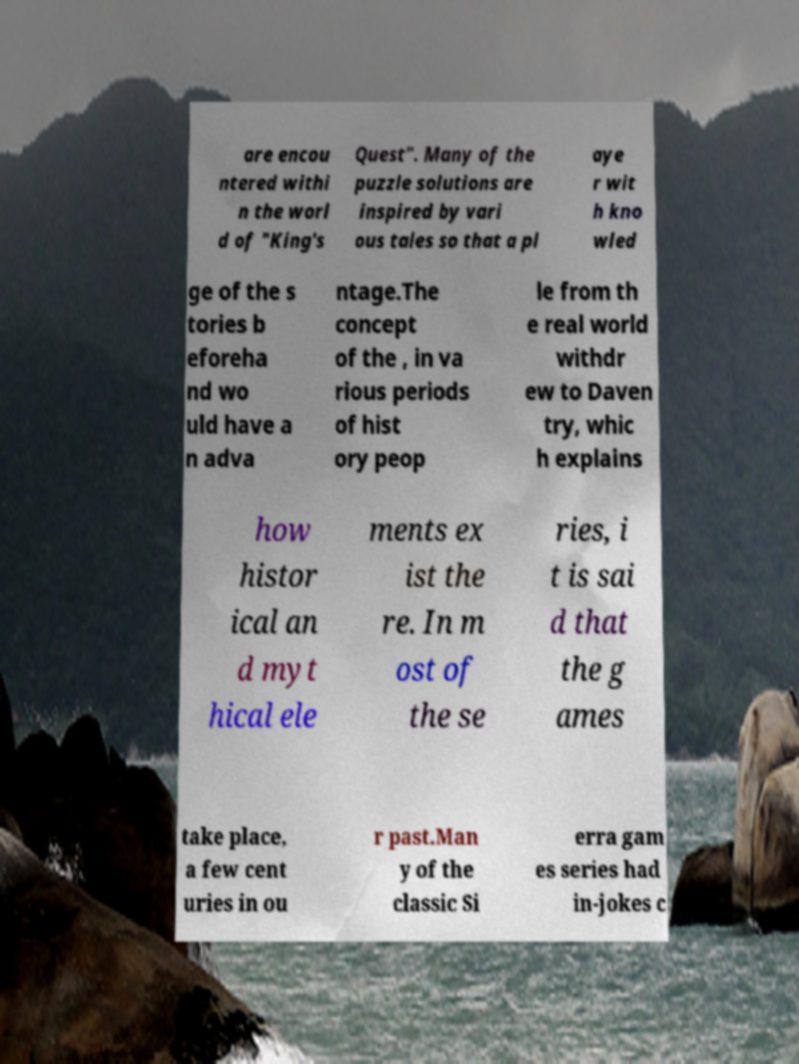Please read and relay the text visible in this image. What does it say? are encou ntered withi n the worl d of "King's Quest". Many of the puzzle solutions are inspired by vari ous tales so that a pl aye r wit h kno wled ge of the s tories b eforeha nd wo uld have a n adva ntage.The concept of the , in va rious periods of hist ory peop le from th e real world withdr ew to Daven try, whic h explains how histor ical an d myt hical ele ments ex ist the re. In m ost of the se ries, i t is sai d that the g ames take place, a few cent uries in ou r past.Man y of the classic Si erra gam es series had in-jokes c 